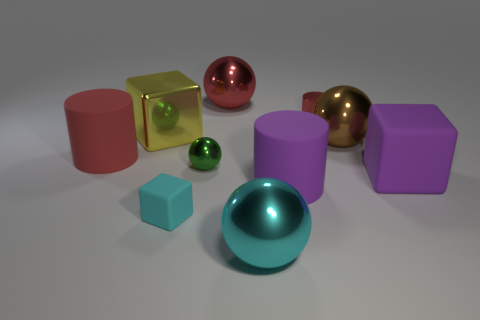Are the small red cylinder and the large sphere that is to the right of the large purple rubber cylinder made of the same material?
Your response must be concise. Yes. The big rubber cube has what color?
Offer a very short reply. Purple. What is the color of the large block to the right of the large cube behind the purple rubber object on the right side of the brown thing?
Ensure brevity in your answer.  Purple. There is a big red matte object; does it have the same shape as the small thing right of the large cyan ball?
Make the answer very short. Yes. There is a cube that is behind the tiny rubber object and on the left side of the large brown object; what color is it?
Ensure brevity in your answer.  Yellow. Are there any purple rubber things that have the same shape as the yellow metal thing?
Provide a short and direct response. Yes. Do the tiny cylinder and the big matte cube have the same color?
Your answer should be compact. No. Is there a tiny rubber thing in front of the big red thing on the right side of the yellow metallic block?
Provide a succinct answer. Yes. How many objects are either cubes that are left of the tiny cyan rubber thing or big objects to the right of the green metallic thing?
Ensure brevity in your answer.  6. What number of things are either cyan rubber blocks or shiny spheres in front of the yellow shiny thing?
Offer a very short reply. 4. 